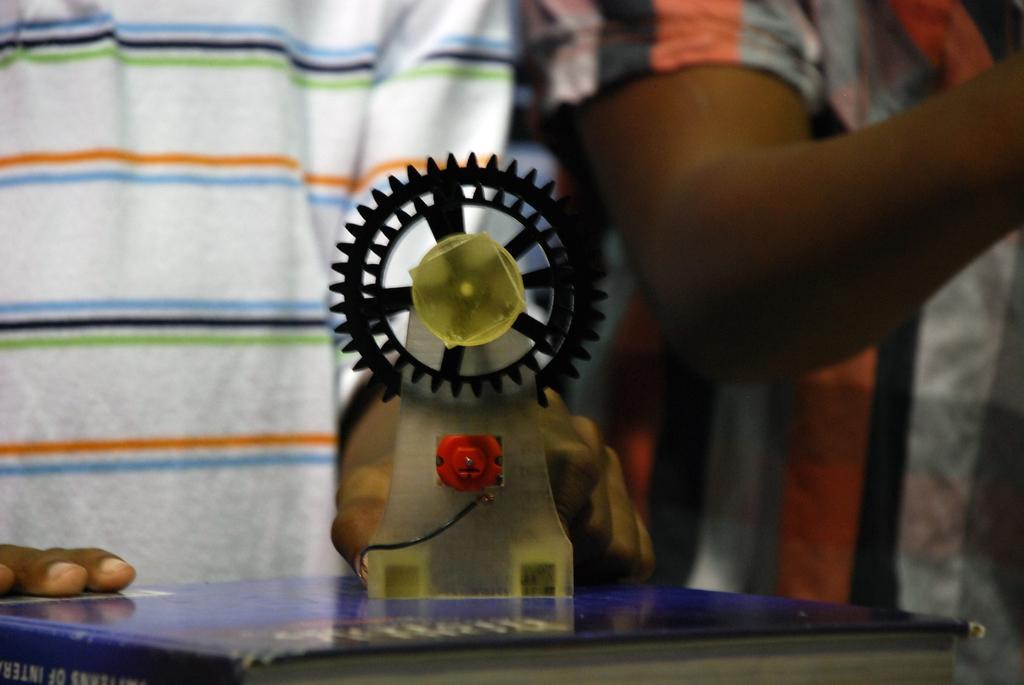How would you summarize this image in a sentence or two? In this image we can see a book and an object. In the background we can see two persons who are truncated. 